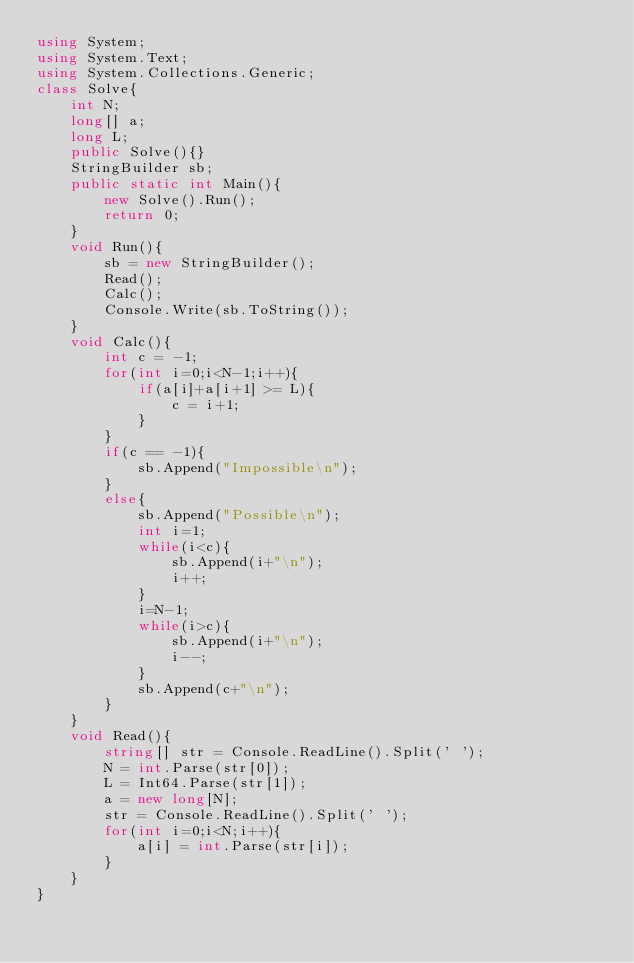Convert code to text. <code><loc_0><loc_0><loc_500><loc_500><_C#_>using System;
using System.Text;
using System.Collections.Generic;
class Solve{
    int N;
    long[] a;
    long L;
    public Solve(){}
    StringBuilder sb;
    public static int Main(){
        new Solve().Run();
        return 0;
    }
    void Run(){
        sb = new StringBuilder();
        Read();
        Calc();
        Console.Write(sb.ToString());
    }
    void Calc(){
        int c = -1;
        for(int i=0;i<N-1;i++){
            if(a[i]+a[i+1] >= L){
                c = i+1;
            }
        }
        if(c == -1){
            sb.Append("Impossible\n");
        }
        else{
            sb.Append("Possible\n");
            int i=1;
            while(i<c){
                sb.Append(i+"\n");
                i++;
            }
            i=N-1;
            while(i>c){
                sb.Append(i+"\n");
                i--;
            }
            sb.Append(c+"\n");
        }
    }
    void Read(){
        string[] str = Console.ReadLine().Split(' ');
        N = int.Parse(str[0]);
        L = Int64.Parse(str[1]);
        a = new long[N];
        str = Console.ReadLine().Split(' ');
        for(int i=0;i<N;i++){
            a[i] = int.Parse(str[i]);
        }
    }    
}</code> 